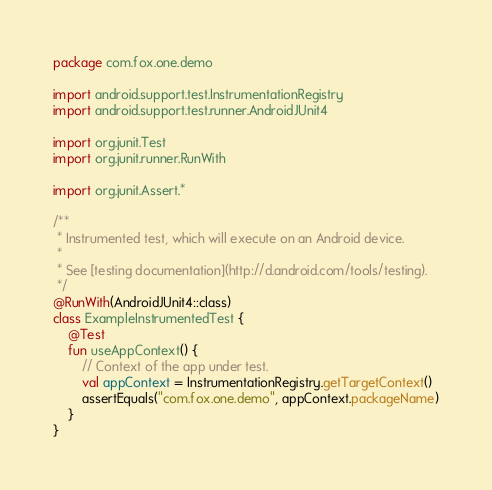<code> <loc_0><loc_0><loc_500><loc_500><_Kotlin_>package com.fox.one.demo

import android.support.test.InstrumentationRegistry
import android.support.test.runner.AndroidJUnit4

import org.junit.Test
import org.junit.runner.RunWith

import org.junit.Assert.*

/**
 * Instrumented test, which will execute on an Android device.
 *
 * See [testing documentation](http://d.android.com/tools/testing).
 */
@RunWith(AndroidJUnit4::class)
class ExampleInstrumentedTest {
    @Test
    fun useAppContext() {
        // Context of the app under test.
        val appContext = InstrumentationRegistry.getTargetContext()
        assertEquals("com.fox.one.demo", appContext.packageName)
    }
}
</code> 